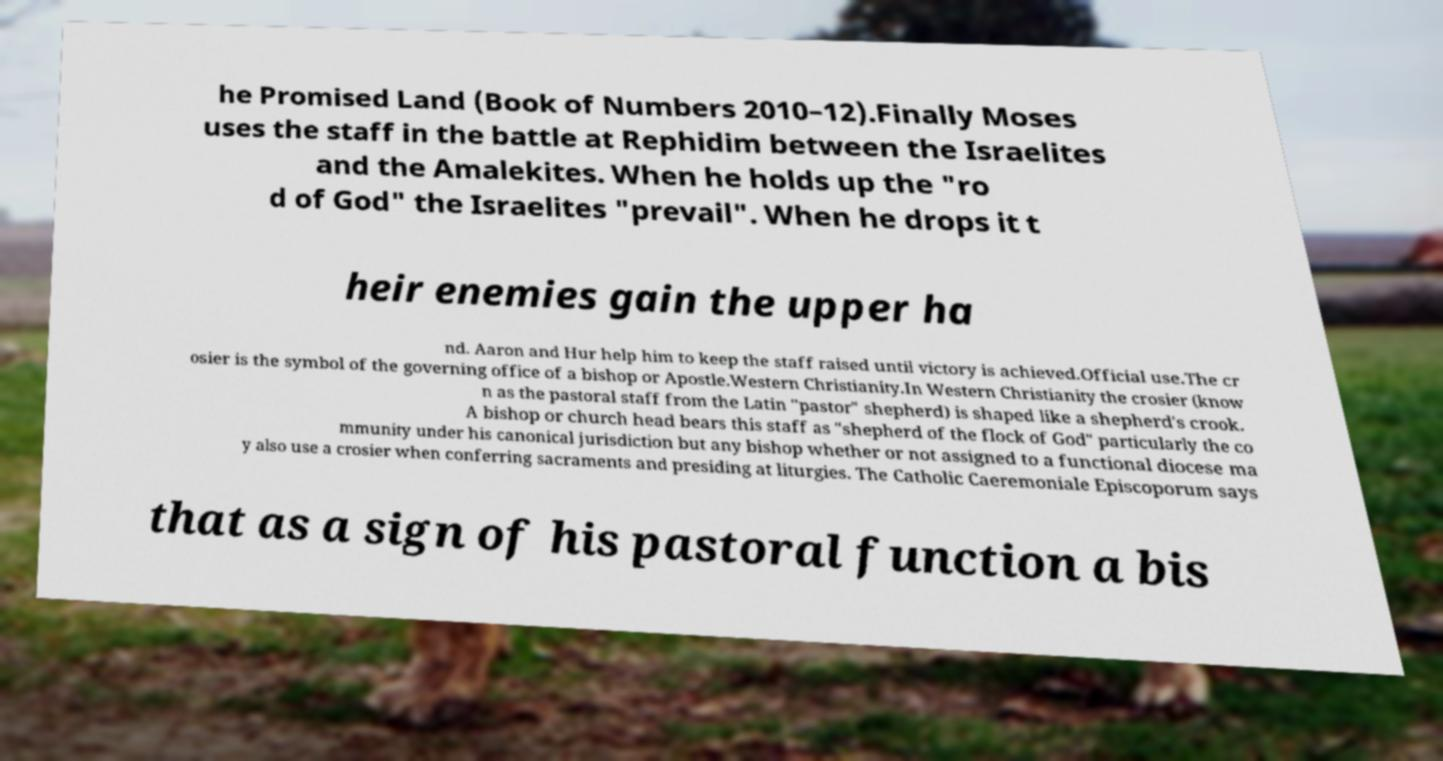Could you assist in decoding the text presented in this image and type it out clearly? he Promised Land (Book of Numbers 2010–12).Finally Moses uses the staff in the battle at Rephidim between the Israelites and the Amalekites. When he holds up the "ro d of God" the Israelites "prevail". When he drops it t heir enemies gain the upper ha nd. Aaron and Hur help him to keep the staff raised until victory is achieved.Official use.The cr osier is the symbol of the governing office of a bishop or Apostle.Western Christianity.In Western Christianity the crosier (know n as the pastoral staff from the Latin "pastor" shepherd) is shaped like a shepherd's crook. A bishop or church head bears this staff as "shepherd of the flock of God" particularly the co mmunity under his canonical jurisdiction but any bishop whether or not assigned to a functional diocese ma y also use a crosier when conferring sacraments and presiding at liturgies. The Catholic Caeremoniale Episcoporum says that as a sign of his pastoral function a bis 